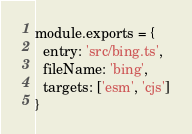<code> <loc_0><loc_0><loc_500><loc_500><_JavaScript_>module.exports = {
  entry: 'src/bing.ts',
  fileName: 'bing',
  targets: ['esm', 'cjs']
}
</code> 